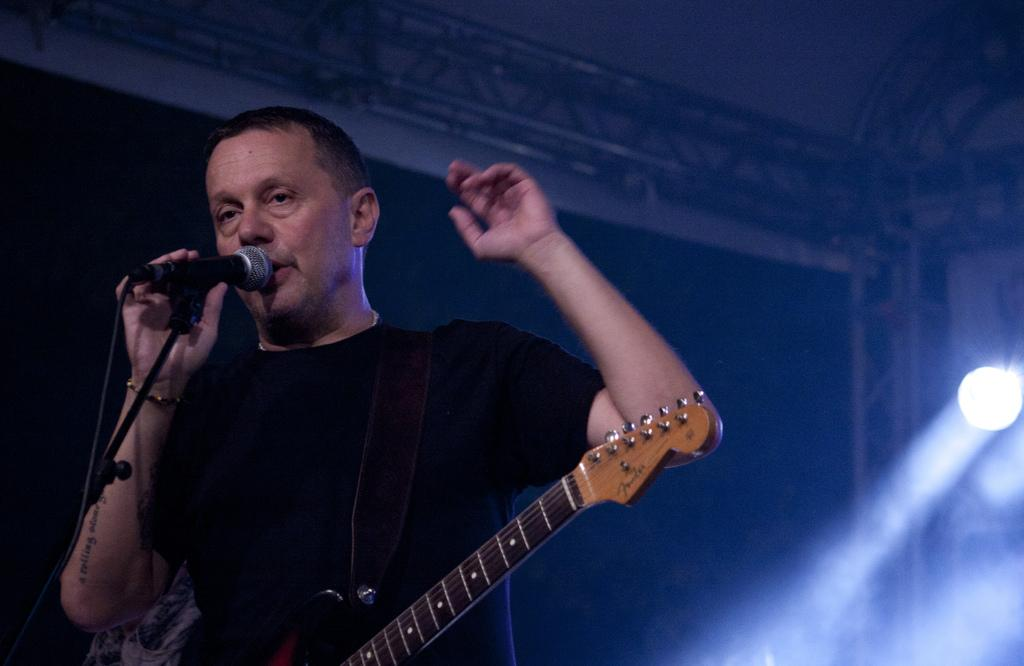What is the main subject of the image? There is a person in the image. What is the person wearing? The person is wearing a black t-shirt. What is the person holding in the image? The person is holding a microphone. What other musical instrument is present in the image? A guitar is placed on the person. What can be seen in the background of the image? There are lights visible in the background. What type of debt is the person in the image trying to pay off? There is no indication of debt in the image; it features a person holding a microphone and wearing a guitar. Can you tell me how many swings are present at the playground in the image? There is no playground present in the image; it features a person with musical instruments and lights in the background. 